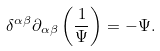<formula> <loc_0><loc_0><loc_500><loc_500>\delta ^ { \alpha \beta } \partial _ { \alpha \beta } \left ( \frac { 1 } { \Psi } \right ) = - \Psi .</formula> 